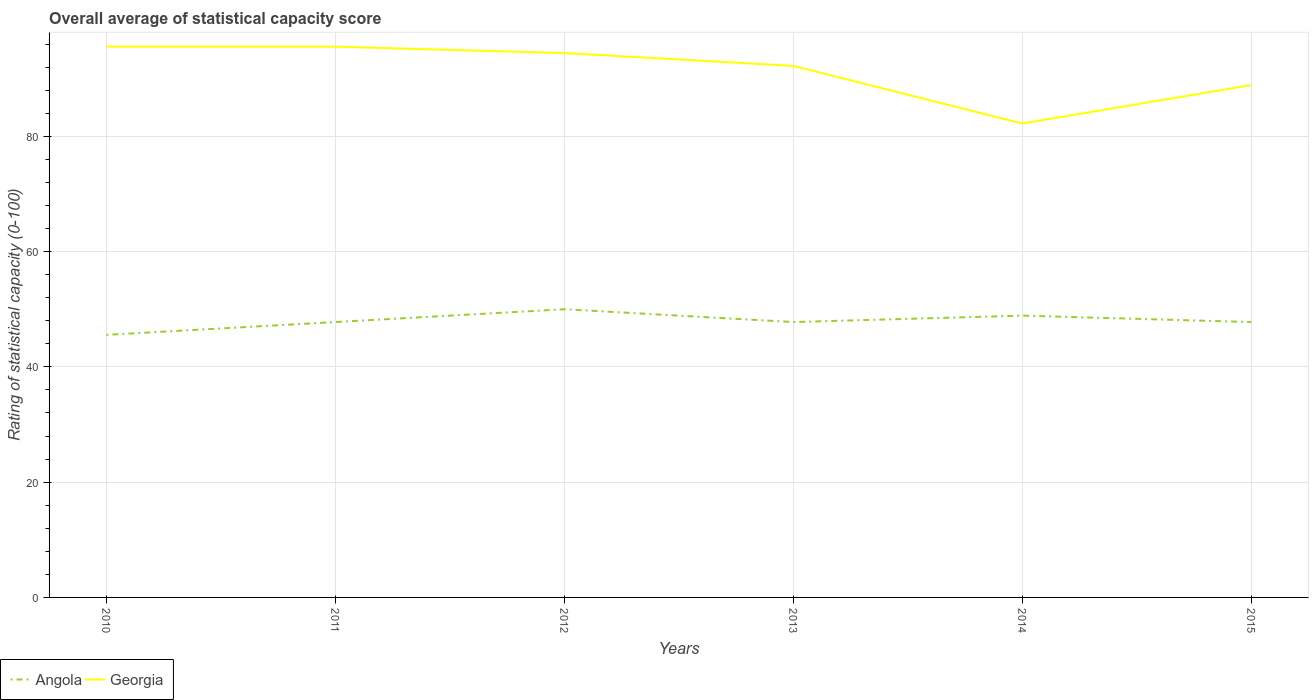Does the line corresponding to Georgia intersect with the line corresponding to Angola?
Offer a very short reply. No. Across all years, what is the maximum rating of statistical capacity in Angola?
Give a very brief answer. 45.56. What is the total rating of statistical capacity in Angola in the graph?
Offer a terse response. -1.11. What is the difference between the highest and the second highest rating of statistical capacity in Georgia?
Offer a very short reply. 13.33. What is the difference between the highest and the lowest rating of statistical capacity in Angola?
Offer a terse response. 2. Is the rating of statistical capacity in Angola strictly greater than the rating of statistical capacity in Georgia over the years?
Make the answer very short. Yes. How many years are there in the graph?
Your answer should be very brief. 6. What is the difference between two consecutive major ticks on the Y-axis?
Offer a terse response. 20. Are the values on the major ticks of Y-axis written in scientific E-notation?
Ensure brevity in your answer.  No. Where does the legend appear in the graph?
Give a very brief answer. Bottom left. What is the title of the graph?
Make the answer very short. Overall average of statistical capacity score. What is the label or title of the Y-axis?
Your response must be concise. Rating of statistical capacity (0-100). What is the Rating of statistical capacity (0-100) in Angola in 2010?
Make the answer very short. 45.56. What is the Rating of statistical capacity (0-100) in Georgia in 2010?
Your answer should be very brief. 95.56. What is the Rating of statistical capacity (0-100) in Angola in 2011?
Offer a terse response. 47.78. What is the Rating of statistical capacity (0-100) in Georgia in 2011?
Your answer should be compact. 95.56. What is the Rating of statistical capacity (0-100) of Angola in 2012?
Your response must be concise. 50. What is the Rating of statistical capacity (0-100) of Georgia in 2012?
Give a very brief answer. 94.44. What is the Rating of statistical capacity (0-100) in Angola in 2013?
Your answer should be compact. 47.78. What is the Rating of statistical capacity (0-100) in Georgia in 2013?
Your answer should be compact. 92.22. What is the Rating of statistical capacity (0-100) of Angola in 2014?
Keep it short and to the point. 48.89. What is the Rating of statistical capacity (0-100) in Georgia in 2014?
Offer a very short reply. 82.22. What is the Rating of statistical capacity (0-100) of Angola in 2015?
Your answer should be very brief. 47.78. What is the Rating of statistical capacity (0-100) of Georgia in 2015?
Your answer should be very brief. 88.89. Across all years, what is the maximum Rating of statistical capacity (0-100) of Angola?
Your answer should be compact. 50. Across all years, what is the maximum Rating of statistical capacity (0-100) in Georgia?
Offer a terse response. 95.56. Across all years, what is the minimum Rating of statistical capacity (0-100) of Angola?
Provide a short and direct response. 45.56. Across all years, what is the minimum Rating of statistical capacity (0-100) in Georgia?
Give a very brief answer. 82.22. What is the total Rating of statistical capacity (0-100) of Angola in the graph?
Give a very brief answer. 287.78. What is the total Rating of statistical capacity (0-100) in Georgia in the graph?
Offer a very short reply. 548.89. What is the difference between the Rating of statistical capacity (0-100) in Angola in 2010 and that in 2011?
Your answer should be very brief. -2.22. What is the difference between the Rating of statistical capacity (0-100) in Angola in 2010 and that in 2012?
Provide a short and direct response. -4.44. What is the difference between the Rating of statistical capacity (0-100) of Georgia in 2010 and that in 2012?
Offer a terse response. 1.11. What is the difference between the Rating of statistical capacity (0-100) in Angola in 2010 and that in 2013?
Keep it short and to the point. -2.22. What is the difference between the Rating of statistical capacity (0-100) in Georgia in 2010 and that in 2014?
Your answer should be very brief. 13.33. What is the difference between the Rating of statistical capacity (0-100) in Angola in 2010 and that in 2015?
Your answer should be compact. -2.22. What is the difference between the Rating of statistical capacity (0-100) of Angola in 2011 and that in 2012?
Your answer should be compact. -2.22. What is the difference between the Rating of statistical capacity (0-100) of Georgia in 2011 and that in 2012?
Your answer should be compact. 1.11. What is the difference between the Rating of statistical capacity (0-100) of Angola in 2011 and that in 2013?
Provide a short and direct response. 0. What is the difference between the Rating of statistical capacity (0-100) of Angola in 2011 and that in 2014?
Ensure brevity in your answer.  -1.11. What is the difference between the Rating of statistical capacity (0-100) in Georgia in 2011 and that in 2014?
Ensure brevity in your answer.  13.33. What is the difference between the Rating of statistical capacity (0-100) of Georgia in 2011 and that in 2015?
Keep it short and to the point. 6.67. What is the difference between the Rating of statistical capacity (0-100) of Angola in 2012 and that in 2013?
Provide a short and direct response. 2.22. What is the difference between the Rating of statistical capacity (0-100) in Georgia in 2012 and that in 2013?
Your answer should be compact. 2.22. What is the difference between the Rating of statistical capacity (0-100) in Angola in 2012 and that in 2014?
Your response must be concise. 1.11. What is the difference between the Rating of statistical capacity (0-100) in Georgia in 2012 and that in 2014?
Your answer should be compact. 12.22. What is the difference between the Rating of statistical capacity (0-100) in Angola in 2012 and that in 2015?
Provide a succinct answer. 2.22. What is the difference between the Rating of statistical capacity (0-100) of Georgia in 2012 and that in 2015?
Ensure brevity in your answer.  5.56. What is the difference between the Rating of statistical capacity (0-100) in Angola in 2013 and that in 2014?
Offer a terse response. -1.11. What is the difference between the Rating of statistical capacity (0-100) of Georgia in 2013 and that in 2015?
Give a very brief answer. 3.33. What is the difference between the Rating of statistical capacity (0-100) of Angola in 2014 and that in 2015?
Make the answer very short. 1.11. What is the difference between the Rating of statistical capacity (0-100) of Georgia in 2014 and that in 2015?
Offer a very short reply. -6.67. What is the difference between the Rating of statistical capacity (0-100) of Angola in 2010 and the Rating of statistical capacity (0-100) of Georgia in 2011?
Your answer should be very brief. -50. What is the difference between the Rating of statistical capacity (0-100) of Angola in 2010 and the Rating of statistical capacity (0-100) of Georgia in 2012?
Make the answer very short. -48.89. What is the difference between the Rating of statistical capacity (0-100) in Angola in 2010 and the Rating of statistical capacity (0-100) in Georgia in 2013?
Your response must be concise. -46.67. What is the difference between the Rating of statistical capacity (0-100) in Angola in 2010 and the Rating of statistical capacity (0-100) in Georgia in 2014?
Your response must be concise. -36.67. What is the difference between the Rating of statistical capacity (0-100) of Angola in 2010 and the Rating of statistical capacity (0-100) of Georgia in 2015?
Offer a terse response. -43.33. What is the difference between the Rating of statistical capacity (0-100) in Angola in 2011 and the Rating of statistical capacity (0-100) in Georgia in 2012?
Your answer should be compact. -46.67. What is the difference between the Rating of statistical capacity (0-100) of Angola in 2011 and the Rating of statistical capacity (0-100) of Georgia in 2013?
Provide a succinct answer. -44.44. What is the difference between the Rating of statistical capacity (0-100) of Angola in 2011 and the Rating of statistical capacity (0-100) of Georgia in 2014?
Your answer should be very brief. -34.44. What is the difference between the Rating of statistical capacity (0-100) of Angola in 2011 and the Rating of statistical capacity (0-100) of Georgia in 2015?
Offer a terse response. -41.11. What is the difference between the Rating of statistical capacity (0-100) of Angola in 2012 and the Rating of statistical capacity (0-100) of Georgia in 2013?
Provide a short and direct response. -42.22. What is the difference between the Rating of statistical capacity (0-100) in Angola in 2012 and the Rating of statistical capacity (0-100) in Georgia in 2014?
Ensure brevity in your answer.  -32.22. What is the difference between the Rating of statistical capacity (0-100) in Angola in 2012 and the Rating of statistical capacity (0-100) in Georgia in 2015?
Ensure brevity in your answer.  -38.89. What is the difference between the Rating of statistical capacity (0-100) of Angola in 2013 and the Rating of statistical capacity (0-100) of Georgia in 2014?
Your response must be concise. -34.44. What is the difference between the Rating of statistical capacity (0-100) of Angola in 2013 and the Rating of statistical capacity (0-100) of Georgia in 2015?
Ensure brevity in your answer.  -41.11. What is the difference between the Rating of statistical capacity (0-100) in Angola in 2014 and the Rating of statistical capacity (0-100) in Georgia in 2015?
Your answer should be very brief. -40. What is the average Rating of statistical capacity (0-100) of Angola per year?
Offer a terse response. 47.96. What is the average Rating of statistical capacity (0-100) of Georgia per year?
Keep it short and to the point. 91.48. In the year 2010, what is the difference between the Rating of statistical capacity (0-100) in Angola and Rating of statistical capacity (0-100) in Georgia?
Provide a succinct answer. -50. In the year 2011, what is the difference between the Rating of statistical capacity (0-100) of Angola and Rating of statistical capacity (0-100) of Georgia?
Your answer should be compact. -47.78. In the year 2012, what is the difference between the Rating of statistical capacity (0-100) in Angola and Rating of statistical capacity (0-100) in Georgia?
Keep it short and to the point. -44.44. In the year 2013, what is the difference between the Rating of statistical capacity (0-100) in Angola and Rating of statistical capacity (0-100) in Georgia?
Keep it short and to the point. -44.44. In the year 2014, what is the difference between the Rating of statistical capacity (0-100) of Angola and Rating of statistical capacity (0-100) of Georgia?
Keep it short and to the point. -33.33. In the year 2015, what is the difference between the Rating of statistical capacity (0-100) in Angola and Rating of statistical capacity (0-100) in Georgia?
Offer a terse response. -41.11. What is the ratio of the Rating of statistical capacity (0-100) in Angola in 2010 to that in 2011?
Make the answer very short. 0.95. What is the ratio of the Rating of statistical capacity (0-100) of Angola in 2010 to that in 2012?
Keep it short and to the point. 0.91. What is the ratio of the Rating of statistical capacity (0-100) in Georgia in 2010 to that in 2012?
Your answer should be compact. 1.01. What is the ratio of the Rating of statistical capacity (0-100) of Angola in 2010 to that in 2013?
Provide a short and direct response. 0.95. What is the ratio of the Rating of statistical capacity (0-100) of Georgia in 2010 to that in 2013?
Make the answer very short. 1.04. What is the ratio of the Rating of statistical capacity (0-100) in Angola in 2010 to that in 2014?
Keep it short and to the point. 0.93. What is the ratio of the Rating of statistical capacity (0-100) of Georgia in 2010 to that in 2014?
Your answer should be very brief. 1.16. What is the ratio of the Rating of statistical capacity (0-100) of Angola in 2010 to that in 2015?
Keep it short and to the point. 0.95. What is the ratio of the Rating of statistical capacity (0-100) of Georgia in 2010 to that in 2015?
Your answer should be compact. 1.07. What is the ratio of the Rating of statistical capacity (0-100) of Angola in 2011 to that in 2012?
Offer a very short reply. 0.96. What is the ratio of the Rating of statistical capacity (0-100) of Georgia in 2011 to that in 2012?
Your answer should be compact. 1.01. What is the ratio of the Rating of statistical capacity (0-100) in Georgia in 2011 to that in 2013?
Provide a succinct answer. 1.04. What is the ratio of the Rating of statistical capacity (0-100) of Angola in 2011 to that in 2014?
Provide a succinct answer. 0.98. What is the ratio of the Rating of statistical capacity (0-100) in Georgia in 2011 to that in 2014?
Offer a terse response. 1.16. What is the ratio of the Rating of statistical capacity (0-100) in Georgia in 2011 to that in 2015?
Ensure brevity in your answer.  1.07. What is the ratio of the Rating of statistical capacity (0-100) of Angola in 2012 to that in 2013?
Make the answer very short. 1.05. What is the ratio of the Rating of statistical capacity (0-100) in Georgia in 2012 to that in 2013?
Make the answer very short. 1.02. What is the ratio of the Rating of statistical capacity (0-100) of Angola in 2012 to that in 2014?
Your answer should be compact. 1.02. What is the ratio of the Rating of statistical capacity (0-100) in Georgia in 2012 to that in 2014?
Offer a very short reply. 1.15. What is the ratio of the Rating of statistical capacity (0-100) in Angola in 2012 to that in 2015?
Make the answer very short. 1.05. What is the ratio of the Rating of statistical capacity (0-100) of Angola in 2013 to that in 2014?
Your answer should be very brief. 0.98. What is the ratio of the Rating of statistical capacity (0-100) of Georgia in 2013 to that in 2014?
Make the answer very short. 1.12. What is the ratio of the Rating of statistical capacity (0-100) in Georgia in 2013 to that in 2015?
Keep it short and to the point. 1.04. What is the ratio of the Rating of statistical capacity (0-100) in Angola in 2014 to that in 2015?
Offer a terse response. 1.02. What is the ratio of the Rating of statistical capacity (0-100) of Georgia in 2014 to that in 2015?
Ensure brevity in your answer.  0.93. What is the difference between the highest and the second highest Rating of statistical capacity (0-100) of Georgia?
Make the answer very short. 0. What is the difference between the highest and the lowest Rating of statistical capacity (0-100) in Angola?
Ensure brevity in your answer.  4.44. What is the difference between the highest and the lowest Rating of statistical capacity (0-100) of Georgia?
Provide a short and direct response. 13.33. 